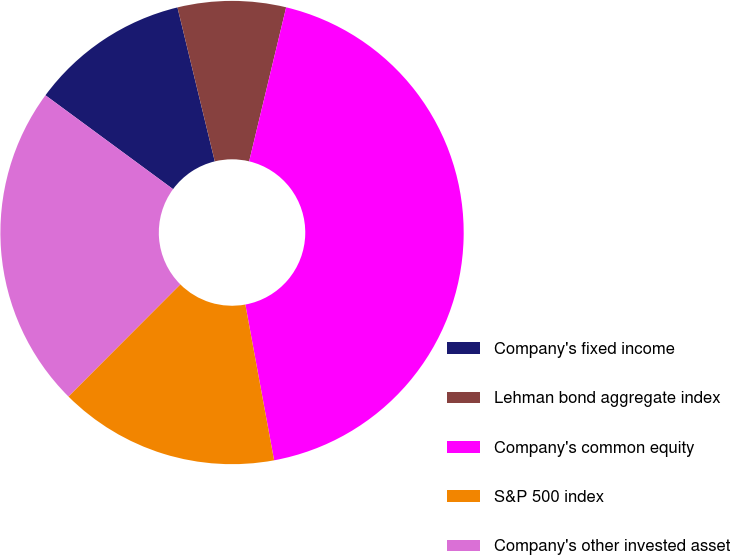Convert chart. <chart><loc_0><loc_0><loc_500><loc_500><pie_chart><fcel>Company's fixed income<fcel>Lehman bond aggregate index<fcel>Company's common equity<fcel>S&P 500 index<fcel>Company's other invested asset<nl><fcel>11.12%<fcel>7.54%<fcel>43.34%<fcel>15.39%<fcel>22.61%<nl></chart> 